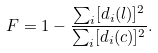<formula> <loc_0><loc_0><loc_500><loc_500>F = 1 - \frac { \sum _ { i } [ d _ { i } ( l ) ] ^ { 2 } } { \sum _ { i } [ d _ { i } ( c ) ] ^ { 2 } } .</formula> 